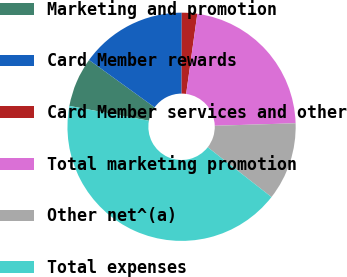Convert chart. <chart><loc_0><loc_0><loc_500><loc_500><pie_chart><fcel>Marketing and promotion<fcel>Card Member rewards<fcel>Card Member services and other<fcel>Total marketing promotion<fcel>Other net^(a)<fcel>Total expenses<nl><fcel>7.03%<fcel>15.07%<fcel>2.18%<fcel>22.3%<fcel>11.05%<fcel>42.37%<nl></chart> 